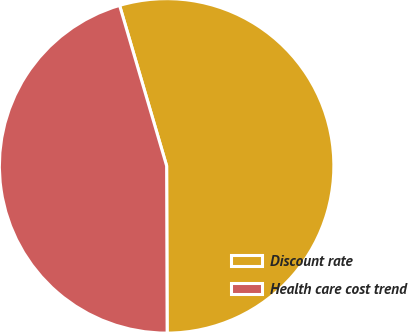<chart> <loc_0><loc_0><loc_500><loc_500><pie_chart><fcel>Discount rate<fcel>Health care cost trend<nl><fcel>54.49%<fcel>45.51%<nl></chart> 